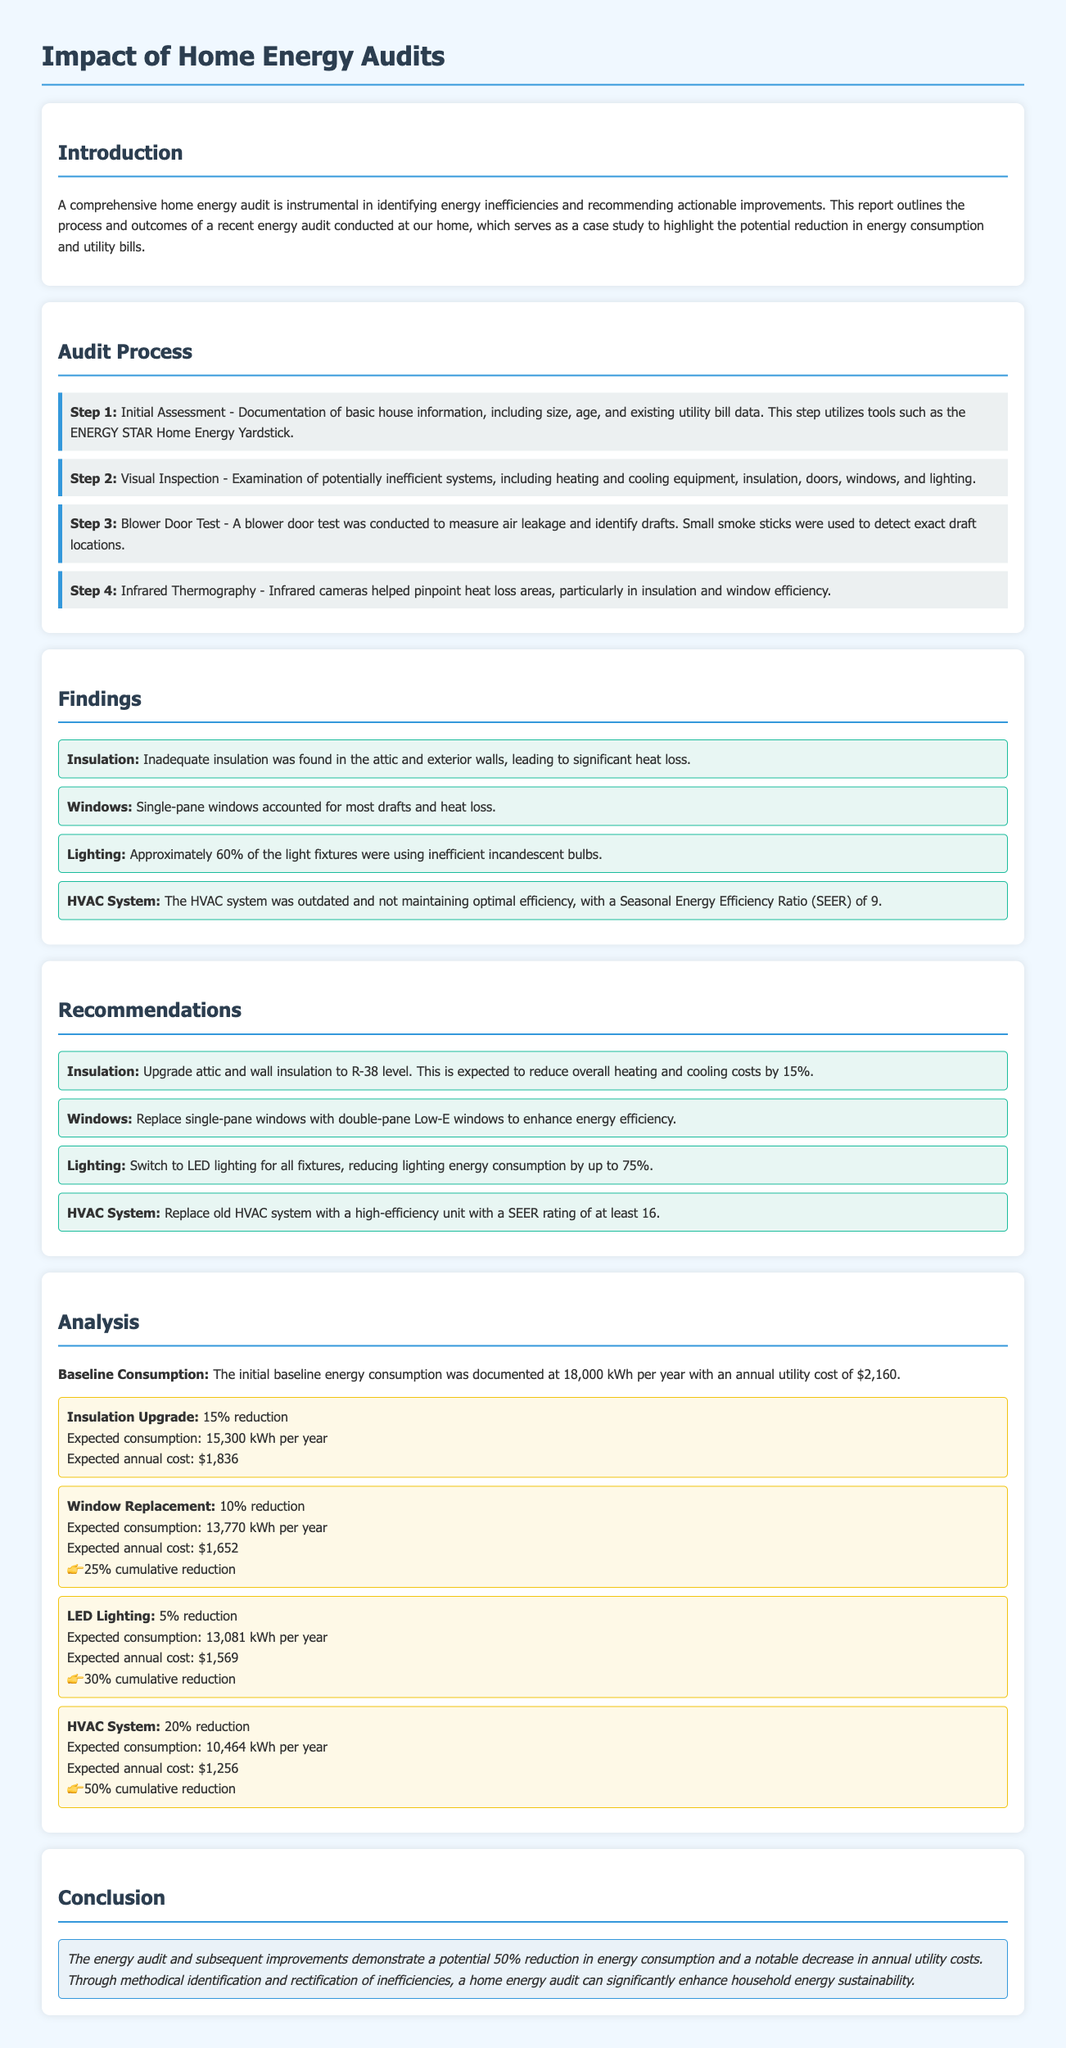What is the main purpose of a home energy audit? The report states that a comprehensive home energy audit is instrumental in identifying energy inefficiencies and recommending actionable improvements.
Answer: Identifying energy inefficiencies and recommending improvements What was the initial baseline energy consumption? The document mentions that the initial baseline energy consumption was documented at 18,000 kWh per year.
Answer: 18,000 kWh What was the expected annual utility cost after the HVAC system upgrade? The analysis shows that after the HVAC system upgrade, the expected annual cost would be $1,256.
Answer: $1,256 What reduction in energy consumption is expected from upgrading insulation? The document states that the expected consumption reduction from upgrading insulation is 15%.
Answer: 15% How much cumulative reduction in energy consumption is achieved after replacing windows? The analysis indicates that replacing windows results in a 25% cumulative reduction in energy consumption.
Answer: 25% What type of lighting is recommended to reduce energy consumption? The recommendations suggest switching to LED lighting for all fixtures.
Answer: LED lighting What is the SEER rating of the outdated HVAC system? The report states that the outdated HVAC system had a Seasonal Energy Efficiency Ratio (SEER) of 9.
Answer: 9 What was one of the methods used during the visual inspection? The document mentions that the visual inspection examined heating and cooling equipment, insulation, and more.
Answer: Examination of heating and cooling equipment What is the expected overall reduction in energy consumption after all improvements? The conclusion indicates that the energy audit could lead to a potential 50% reduction in energy consumption.
Answer: 50% 